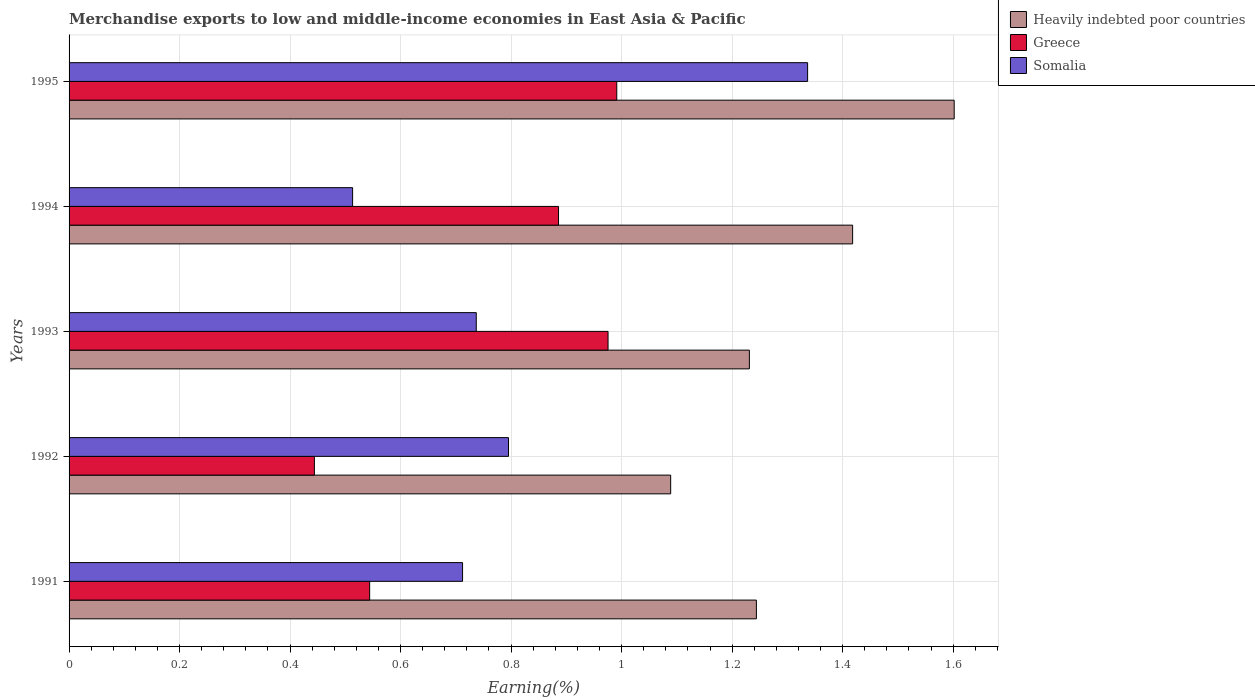How many different coloured bars are there?
Your answer should be very brief. 3. Are the number of bars per tick equal to the number of legend labels?
Your answer should be very brief. Yes. Are the number of bars on each tick of the Y-axis equal?
Your answer should be compact. Yes. How many bars are there on the 5th tick from the bottom?
Provide a short and direct response. 3. What is the percentage of amount earned from merchandise exports in Somalia in 1992?
Your answer should be compact. 0.8. Across all years, what is the maximum percentage of amount earned from merchandise exports in Greece?
Provide a short and direct response. 0.99. Across all years, what is the minimum percentage of amount earned from merchandise exports in Heavily indebted poor countries?
Provide a succinct answer. 1.09. In which year was the percentage of amount earned from merchandise exports in Somalia maximum?
Your answer should be compact. 1995. In which year was the percentage of amount earned from merchandise exports in Somalia minimum?
Make the answer very short. 1994. What is the total percentage of amount earned from merchandise exports in Heavily indebted poor countries in the graph?
Provide a short and direct response. 6.58. What is the difference between the percentage of amount earned from merchandise exports in Greece in 1991 and that in 1992?
Your answer should be compact. 0.1. What is the difference between the percentage of amount earned from merchandise exports in Somalia in 1991 and the percentage of amount earned from merchandise exports in Heavily indebted poor countries in 1995?
Offer a very short reply. -0.89. What is the average percentage of amount earned from merchandise exports in Greece per year?
Your answer should be very brief. 0.77. In the year 1995, what is the difference between the percentage of amount earned from merchandise exports in Greece and percentage of amount earned from merchandise exports in Somalia?
Your response must be concise. -0.35. In how many years, is the percentage of amount earned from merchandise exports in Greece greater than 1.2000000000000002 %?
Ensure brevity in your answer.  0. What is the ratio of the percentage of amount earned from merchandise exports in Somalia in 1992 to that in 1994?
Your response must be concise. 1.55. Is the difference between the percentage of amount earned from merchandise exports in Greece in 1992 and 1995 greater than the difference between the percentage of amount earned from merchandise exports in Somalia in 1992 and 1995?
Offer a very short reply. No. What is the difference between the highest and the second highest percentage of amount earned from merchandise exports in Somalia?
Keep it short and to the point. 0.54. What is the difference between the highest and the lowest percentage of amount earned from merchandise exports in Heavily indebted poor countries?
Give a very brief answer. 0.51. In how many years, is the percentage of amount earned from merchandise exports in Heavily indebted poor countries greater than the average percentage of amount earned from merchandise exports in Heavily indebted poor countries taken over all years?
Your answer should be very brief. 2. Is the sum of the percentage of amount earned from merchandise exports in Somalia in 1993 and 1994 greater than the maximum percentage of amount earned from merchandise exports in Heavily indebted poor countries across all years?
Ensure brevity in your answer.  No. What does the 2nd bar from the top in 1995 represents?
Offer a very short reply. Greece. How many bars are there?
Provide a succinct answer. 15. How many years are there in the graph?
Provide a succinct answer. 5. What is the difference between two consecutive major ticks on the X-axis?
Offer a terse response. 0.2. Does the graph contain any zero values?
Provide a succinct answer. No. Does the graph contain grids?
Ensure brevity in your answer.  Yes. Where does the legend appear in the graph?
Keep it short and to the point. Top right. How many legend labels are there?
Give a very brief answer. 3. What is the title of the graph?
Give a very brief answer. Merchandise exports to low and middle-income economies in East Asia & Pacific. Does "Uruguay" appear as one of the legend labels in the graph?
Give a very brief answer. No. What is the label or title of the X-axis?
Provide a succinct answer. Earning(%). What is the label or title of the Y-axis?
Your answer should be compact. Years. What is the Earning(%) of Heavily indebted poor countries in 1991?
Keep it short and to the point. 1.24. What is the Earning(%) in Greece in 1991?
Your answer should be compact. 0.54. What is the Earning(%) in Somalia in 1991?
Provide a succinct answer. 0.71. What is the Earning(%) of Heavily indebted poor countries in 1992?
Your answer should be compact. 1.09. What is the Earning(%) in Greece in 1992?
Your answer should be very brief. 0.44. What is the Earning(%) in Somalia in 1992?
Give a very brief answer. 0.8. What is the Earning(%) of Heavily indebted poor countries in 1993?
Give a very brief answer. 1.23. What is the Earning(%) in Greece in 1993?
Offer a very short reply. 0.98. What is the Earning(%) in Somalia in 1993?
Give a very brief answer. 0.74. What is the Earning(%) of Heavily indebted poor countries in 1994?
Provide a short and direct response. 1.42. What is the Earning(%) of Greece in 1994?
Keep it short and to the point. 0.89. What is the Earning(%) of Somalia in 1994?
Provide a short and direct response. 0.51. What is the Earning(%) of Heavily indebted poor countries in 1995?
Keep it short and to the point. 1.6. What is the Earning(%) in Greece in 1995?
Provide a short and direct response. 0.99. What is the Earning(%) of Somalia in 1995?
Your answer should be very brief. 1.34. Across all years, what is the maximum Earning(%) in Heavily indebted poor countries?
Keep it short and to the point. 1.6. Across all years, what is the maximum Earning(%) of Greece?
Ensure brevity in your answer.  0.99. Across all years, what is the maximum Earning(%) in Somalia?
Your answer should be compact. 1.34. Across all years, what is the minimum Earning(%) of Heavily indebted poor countries?
Offer a very short reply. 1.09. Across all years, what is the minimum Earning(%) of Greece?
Your answer should be very brief. 0.44. Across all years, what is the minimum Earning(%) in Somalia?
Make the answer very short. 0.51. What is the total Earning(%) in Heavily indebted poor countries in the graph?
Make the answer very short. 6.58. What is the total Earning(%) in Greece in the graph?
Keep it short and to the point. 3.84. What is the total Earning(%) of Somalia in the graph?
Ensure brevity in your answer.  4.09. What is the difference between the Earning(%) in Heavily indebted poor countries in 1991 and that in 1992?
Offer a terse response. 0.16. What is the difference between the Earning(%) in Somalia in 1991 and that in 1992?
Give a very brief answer. -0.08. What is the difference between the Earning(%) in Heavily indebted poor countries in 1991 and that in 1993?
Offer a terse response. 0.01. What is the difference between the Earning(%) in Greece in 1991 and that in 1993?
Ensure brevity in your answer.  -0.43. What is the difference between the Earning(%) of Somalia in 1991 and that in 1993?
Make the answer very short. -0.02. What is the difference between the Earning(%) in Heavily indebted poor countries in 1991 and that in 1994?
Provide a succinct answer. -0.17. What is the difference between the Earning(%) in Greece in 1991 and that in 1994?
Make the answer very short. -0.34. What is the difference between the Earning(%) in Somalia in 1991 and that in 1994?
Provide a short and direct response. 0.2. What is the difference between the Earning(%) of Heavily indebted poor countries in 1991 and that in 1995?
Provide a succinct answer. -0.36. What is the difference between the Earning(%) in Greece in 1991 and that in 1995?
Offer a terse response. -0.45. What is the difference between the Earning(%) of Somalia in 1991 and that in 1995?
Offer a very short reply. -0.62. What is the difference between the Earning(%) in Heavily indebted poor countries in 1992 and that in 1993?
Offer a terse response. -0.14. What is the difference between the Earning(%) of Greece in 1992 and that in 1993?
Make the answer very short. -0.53. What is the difference between the Earning(%) of Somalia in 1992 and that in 1993?
Your response must be concise. 0.06. What is the difference between the Earning(%) in Heavily indebted poor countries in 1992 and that in 1994?
Provide a succinct answer. -0.33. What is the difference between the Earning(%) of Greece in 1992 and that in 1994?
Ensure brevity in your answer.  -0.44. What is the difference between the Earning(%) in Somalia in 1992 and that in 1994?
Keep it short and to the point. 0.28. What is the difference between the Earning(%) in Heavily indebted poor countries in 1992 and that in 1995?
Offer a terse response. -0.51. What is the difference between the Earning(%) of Greece in 1992 and that in 1995?
Ensure brevity in your answer.  -0.55. What is the difference between the Earning(%) of Somalia in 1992 and that in 1995?
Your answer should be compact. -0.54. What is the difference between the Earning(%) of Heavily indebted poor countries in 1993 and that in 1994?
Offer a terse response. -0.19. What is the difference between the Earning(%) in Greece in 1993 and that in 1994?
Your answer should be very brief. 0.09. What is the difference between the Earning(%) of Somalia in 1993 and that in 1994?
Offer a terse response. 0.22. What is the difference between the Earning(%) of Heavily indebted poor countries in 1993 and that in 1995?
Give a very brief answer. -0.37. What is the difference between the Earning(%) of Greece in 1993 and that in 1995?
Make the answer very short. -0.02. What is the difference between the Earning(%) in Somalia in 1993 and that in 1995?
Your response must be concise. -0.6. What is the difference between the Earning(%) in Heavily indebted poor countries in 1994 and that in 1995?
Offer a terse response. -0.18. What is the difference between the Earning(%) of Greece in 1994 and that in 1995?
Your response must be concise. -0.11. What is the difference between the Earning(%) of Somalia in 1994 and that in 1995?
Offer a very short reply. -0.82. What is the difference between the Earning(%) in Heavily indebted poor countries in 1991 and the Earning(%) in Greece in 1992?
Ensure brevity in your answer.  0.8. What is the difference between the Earning(%) in Heavily indebted poor countries in 1991 and the Earning(%) in Somalia in 1992?
Make the answer very short. 0.45. What is the difference between the Earning(%) of Greece in 1991 and the Earning(%) of Somalia in 1992?
Give a very brief answer. -0.25. What is the difference between the Earning(%) in Heavily indebted poor countries in 1991 and the Earning(%) in Greece in 1993?
Ensure brevity in your answer.  0.27. What is the difference between the Earning(%) in Heavily indebted poor countries in 1991 and the Earning(%) in Somalia in 1993?
Your response must be concise. 0.51. What is the difference between the Earning(%) of Greece in 1991 and the Earning(%) of Somalia in 1993?
Your answer should be compact. -0.19. What is the difference between the Earning(%) of Heavily indebted poor countries in 1991 and the Earning(%) of Greece in 1994?
Ensure brevity in your answer.  0.36. What is the difference between the Earning(%) of Heavily indebted poor countries in 1991 and the Earning(%) of Somalia in 1994?
Give a very brief answer. 0.73. What is the difference between the Earning(%) of Greece in 1991 and the Earning(%) of Somalia in 1994?
Offer a terse response. 0.03. What is the difference between the Earning(%) of Heavily indebted poor countries in 1991 and the Earning(%) of Greece in 1995?
Your answer should be very brief. 0.25. What is the difference between the Earning(%) in Heavily indebted poor countries in 1991 and the Earning(%) in Somalia in 1995?
Your response must be concise. -0.09. What is the difference between the Earning(%) in Greece in 1991 and the Earning(%) in Somalia in 1995?
Ensure brevity in your answer.  -0.79. What is the difference between the Earning(%) of Heavily indebted poor countries in 1992 and the Earning(%) of Greece in 1993?
Give a very brief answer. 0.11. What is the difference between the Earning(%) in Heavily indebted poor countries in 1992 and the Earning(%) in Somalia in 1993?
Provide a short and direct response. 0.35. What is the difference between the Earning(%) of Greece in 1992 and the Earning(%) of Somalia in 1993?
Offer a terse response. -0.29. What is the difference between the Earning(%) of Heavily indebted poor countries in 1992 and the Earning(%) of Greece in 1994?
Keep it short and to the point. 0.2. What is the difference between the Earning(%) of Heavily indebted poor countries in 1992 and the Earning(%) of Somalia in 1994?
Offer a very short reply. 0.58. What is the difference between the Earning(%) in Greece in 1992 and the Earning(%) in Somalia in 1994?
Your answer should be compact. -0.07. What is the difference between the Earning(%) in Heavily indebted poor countries in 1992 and the Earning(%) in Greece in 1995?
Offer a very short reply. 0.1. What is the difference between the Earning(%) of Heavily indebted poor countries in 1992 and the Earning(%) of Somalia in 1995?
Provide a short and direct response. -0.25. What is the difference between the Earning(%) of Greece in 1992 and the Earning(%) of Somalia in 1995?
Keep it short and to the point. -0.89. What is the difference between the Earning(%) of Heavily indebted poor countries in 1993 and the Earning(%) of Greece in 1994?
Your response must be concise. 0.35. What is the difference between the Earning(%) of Heavily indebted poor countries in 1993 and the Earning(%) of Somalia in 1994?
Provide a short and direct response. 0.72. What is the difference between the Earning(%) in Greece in 1993 and the Earning(%) in Somalia in 1994?
Make the answer very short. 0.46. What is the difference between the Earning(%) in Heavily indebted poor countries in 1993 and the Earning(%) in Greece in 1995?
Offer a very short reply. 0.24. What is the difference between the Earning(%) of Heavily indebted poor countries in 1993 and the Earning(%) of Somalia in 1995?
Offer a terse response. -0.11. What is the difference between the Earning(%) of Greece in 1993 and the Earning(%) of Somalia in 1995?
Make the answer very short. -0.36. What is the difference between the Earning(%) of Heavily indebted poor countries in 1994 and the Earning(%) of Greece in 1995?
Provide a succinct answer. 0.43. What is the difference between the Earning(%) in Heavily indebted poor countries in 1994 and the Earning(%) in Somalia in 1995?
Give a very brief answer. 0.08. What is the difference between the Earning(%) in Greece in 1994 and the Earning(%) in Somalia in 1995?
Your answer should be compact. -0.45. What is the average Earning(%) in Heavily indebted poor countries per year?
Your answer should be very brief. 1.32. What is the average Earning(%) of Greece per year?
Your answer should be compact. 0.77. What is the average Earning(%) of Somalia per year?
Your response must be concise. 0.82. In the year 1991, what is the difference between the Earning(%) in Heavily indebted poor countries and Earning(%) in Greece?
Keep it short and to the point. 0.7. In the year 1991, what is the difference between the Earning(%) in Heavily indebted poor countries and Earning(%) in Somalia?
Offer a very short reply. 0.53. In the year 1991, what is the difference between the Earning(%) of Greece and Earning(%) of Somalia?
Your response must be concise. -0.17. In the year 1992, what is the difference between the Earning(%) in Heavily indebted poor countries and Earning(%) in Greece?
Make the answer very short. 0.64. In the year 1992, what is the difference between the Earning(%) of Heavily indebted poor countries and Earning(%) of Somalia?
Your answer should be compact. 0.29. In the year 1992, what is the difference between the Earning(%) of Greece and Earning(%) of Somalia?
Make the answer very short. -0.35. In the year 1993, what is the difference between the Earning(%) in Heavily indebted poor countries and Earning(%) in Greece?
Your answer should be very brief. 0.26. In the year 1993, what is the difference between the Earning(%) of Heavily indebted poor countries and Earning(%) of Somalia?
Ensure brevity in your answer.  0.49. In the year 1993, what is the difference between the Earning(%) of Greece and Earning(%) of Somalia?
Offer a terse response. 0.24. In the year 1994, what is the difference between the Earning(%) in Heavily indebted poor countries and Earning(%) in Greece?
Ensure brevity in your answer.  0.53. In the year 1994, what is the difference between the Earning(%) of Heavily indebted poor countries and Earning(%) of Somalia?
Offer a very short reply. 0.91. In the year 1994, what is the difference between the Earning(%) of Greece and Earning(%) of Somalia?
Offer a very short reply. 0.37. In the year 1995, what is the difference between the Earning(%) of Heavily indebted poor countries and Earning(%) of Greece?
Offer a terse response. 0.61. In the year 1995, what is the difference between the Earning(%) of Heavily indebted poor countries and Earning(%) of Somalia?
Make the answer very short. 0.27. In the year 1995, what is the difference between the Earning(%) of Greece and Earning(%) of Somalia?
Offer a terse response. -0.35. What is the ratio of the Earning(%) in Heavily indebted poor countries in 1991 to that in 1992?
Ensure brevity in your answer.  1.14. What is the ratio of the Earning(%) of Greece in 1991 to that in 1992?
Keep it short and to the point. 1.23. What is the ratio of the Earning(%) of Somalia in 1991 to that in 1992?
Offer a very short reply. 0.9. What is the ratio of the Earning(%) of Heavily indebted poor countries in 1991 to that in 1993?
Offer a terse response. 1.01. What is the ratio of the Earning(%) in Greece in 1991 to that in 1993?
Your answer should be compact. 0.56. What is the ratio of the Earning(%) in Somalia in 1991 to that in 1993?
Offer a very short reply. 0.97. What is the ratio of the Earning(%) in Heavily indebted poor countries in 1991 to that in 1994?
Provide a short and direct response. 0.88. What is the ratio of the Earning(%) of Greece in 1991 to that in 1994?
Provide a short and direct response. 0.61. What is the ratio of the Earning(%) in Somalia in 1991 to that in 1994?
Offer a very short reply. 1.39. What is the ratio of the Earning(%) in Heavily indebted poor countries in 1991 to that in 1995?
Provide a short and direct response. 0.78. What is the ratio of the Earning(%) in Greece in 1991 to that in 1995?
Ensure brevity in your answer.  0.55. What is the ratio of the Earning(%) in Somalia in 1991 to that in 1995?
Your response must be concise. 0.53. What is the ratio of the Earning(%) in Heavily indebted poor countries in 1992 to that in 1993?
Your response must be concise. 0.88. What is the ratio of the Earning(%) of Greece in 1992 to that in 1993?
Offer a very short reply. 0.46. What is the ratio of the Earning(%) of Somalia in 1992 to that in 1993?
Your answer should be compact. 1.08. What is the ratio of the Earning(%) of Heavily indebted poor countries in 1992 to that in 1994?
Your answer should be very brief. 0.77. What is the ratio of the Earning(%) of Greece in 1992 to that in 1994?
Your response must be concise. 0.5. What is the ratio of the Earning(%) in Somalia in 1992 to that in 1994?
Give a very brief answer. 1.55. What is the ratio of the Earning(%) in Heavily indebted poor countries in 1992 to that in 1995?
Your answer should be very brief. 0.68. What is the ratio of the Earning(%) of Greece in 1992 to that in 1995?
Your answer should be very brief. 0.45. What is the ratio of the Earning(%) in Somalia in 1992 to that in 1995?
Provide a short and direct response. 0.59. What is the ratio of the Earning(%) of Heavily indebted poor countries in 1993 to that in 1994?
Provide a short and direct response. 0.87. What is the ratio of the Earning(%) of Greece in 1993 to that in 1994?
Ensure brevity in your answer.  1.1. What is the ratio of the Earning(%) of Somalia in 1993 to that in 1994?
Offer a terse response. 1.44. What is the ratio of the Earning(%) in Heavily indebted poor countries in 1993 to that in 1995?
Ensure brevity in your answer.  0.77. What is the ratio of the Earning(%) of Greece in 1993 to that in 1995?
Provide a succinct answer. 0.98. What is the ratio of the Earning(%) of Somalia in 1993 to that in 1995?
Make the answer very short. 0.55. What is the ratio of the Earning(%) of Heavily indebted poor countries in 1994 to that in 1995?
Provide a succinct answer. 0.89. What is the ratio of the Earning(%) of Greece in 1994 to that in 1995?
Provide a succinct answer. 0.89. What is the ratio of the Earning(%) of Somalia in 1994 to that in 1995?
Offer a terse response. 0.38. What is the difference between the highest and the second highest Earning(%) in Heavily indebted poor countries?
Your response must be concise. 0.18. What is the difference between the highest and the second highest Earning(%) in Greece?
Keep it short and to the point. 0.02. What is the difference between the highest and the second highest Earning(%) in Somalia?
Your response must be concise. 0.54. What is the difference between the highest and the lowest Earning(%) of Heavily indebted poor countries?
Offer a very short reply. 0.51. What is the difference between the highest and the lowest Earning(%) of Greece?
Give a very brief answer. 0.55. What is the difference between the highest and the lowest Earning(%) in Somalia?
Provide a short and direct response. 0.82. 